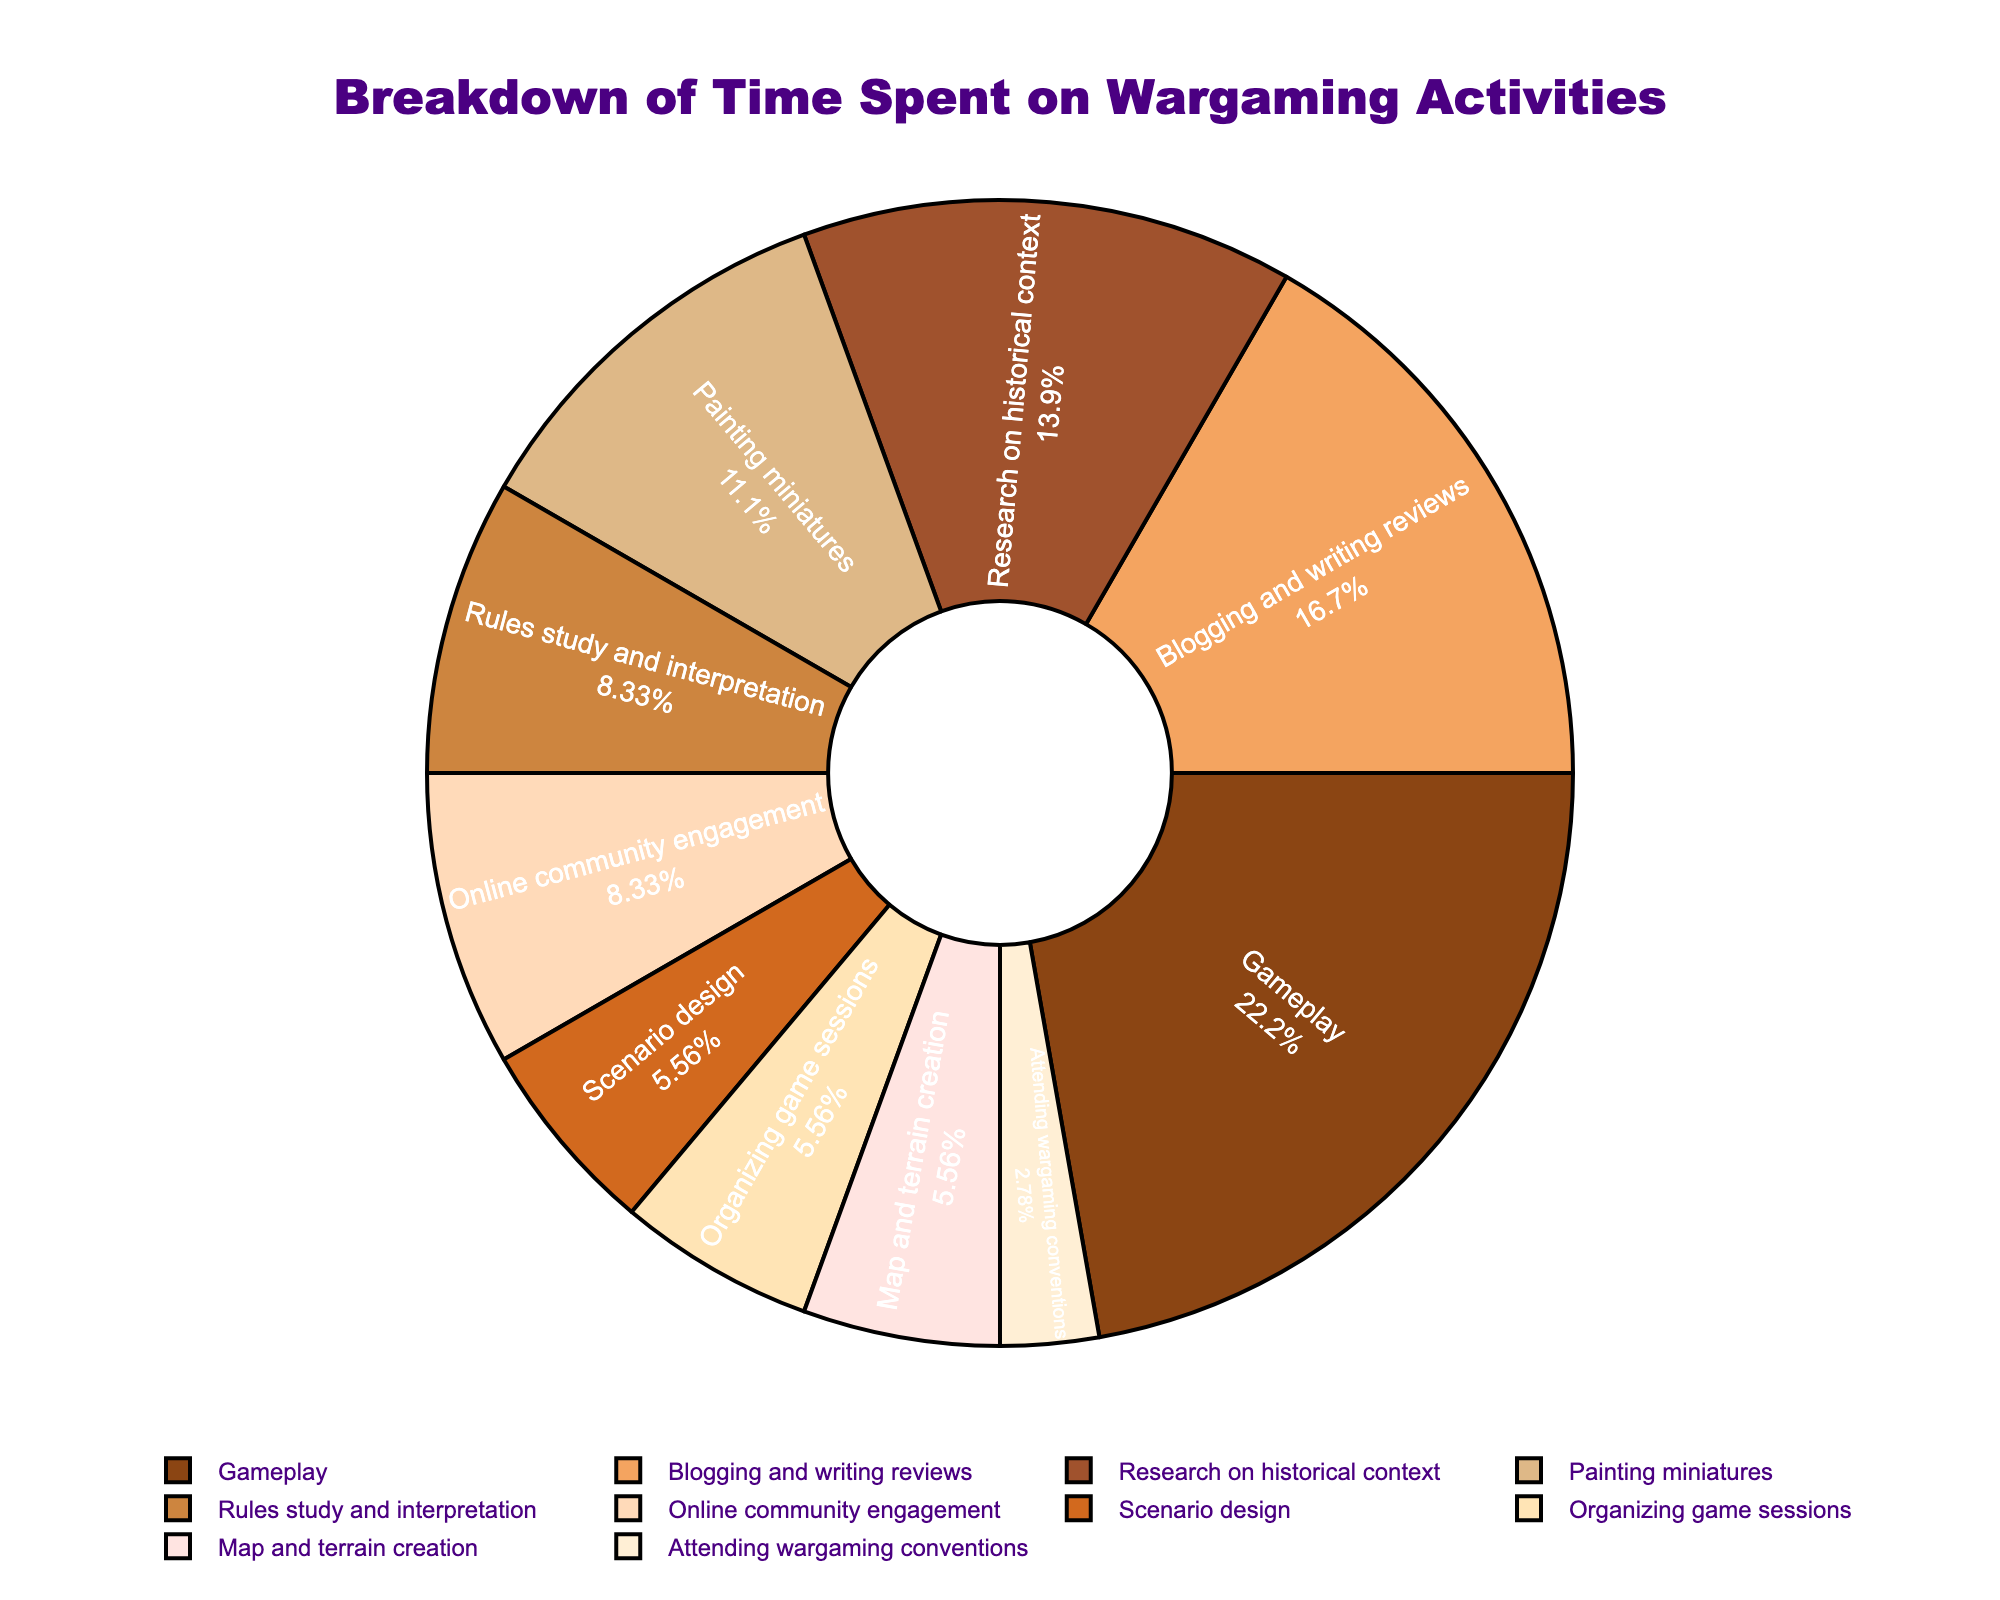Which activity takes up the most time in the pie chart? According to the pie chart, the activity labeled "Gameplay" occupies the largest segment of the pie chart, indicating it takes up the most time per week.
Answer: Gameplay How much more time is spent blogging and writing reviews compared to research on historical context? Blogging and writing reviews takes 6 hours per week, while research on historical context takes 5 hours. The difference is 6 - 5 = 1 hour.
Answer: 1 hour What proportion of time is dedicated to painting miniatures versus gameplay? According to the pie chart, painting miniatures takes up a smaller segment than gameplay. Painting miniatures occupies 4 hours per week, whereas gameplay occupies 8 hours. The ratio is 4/8 or 1:2.
Answer: 1:2 Which activities are allocated 2 hours per week? The pie chart shows that "Scenario design," "Organizing game sessions," and "Map and terrain creation" are each allocated 2 hours per week.
Answer: Scenario design, Organizing game sessions, Map and terrain creation What is the percentage of time spent on online community engagement? The pie chart shows the percentage value for each activity inside each segment. For online community engagement, it is indicated to occupy part of the pie chart, and upon checking, it is 10%.
Answer: 10% How many hours in total are spent on activities that require research or preparation, such as research on historical context, rules study and interpretation, and map and terrain creation? Adding the hours for these activities: research on historical context (5 hours), rules study and interpretation (3 hours), and map and terrain creation (2 hours) gives 5 + 3 + 2 = 10 hours.
Answer: 10 hours Is more time spent on attending wargaming conventions or organizing game sessions? The pie chart shows that attending wargaming conventions accounts for 1 hour per week, while organizing game sessions accounts for 2 hours per week. Therefore, more time is spent on organizing game sessions.
Answer: Organizing game sessions What is the combined percentage of time spent on scenario design and map and terrain creation? Scenario design and map and terrain creation each occupy 2 hours per week. The combined hours are 2 + 2 = 4 hours. To find the percentage, calculate (4/36)*100%. The total hours sum to 36. Therefore, (4/36)*100% equals approximately 11.1%.
Answer: Approximately 11.1% What color represents research on historical context in the pie chart, and how much time is spent on it? The pie chart uses a specific color to represent each activity. Research on historical context is typically shown as the second segment from the start point (90 degrees rotation), and it is colored as indicated by the second color in the custom palette. Amount of time spent on this activity is 5 hours per week.
Answer: Brown, 5 hours 